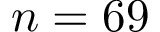<formula> <loc_0><loc_0><loc_500><loc_500>n = 6 9</formula> 